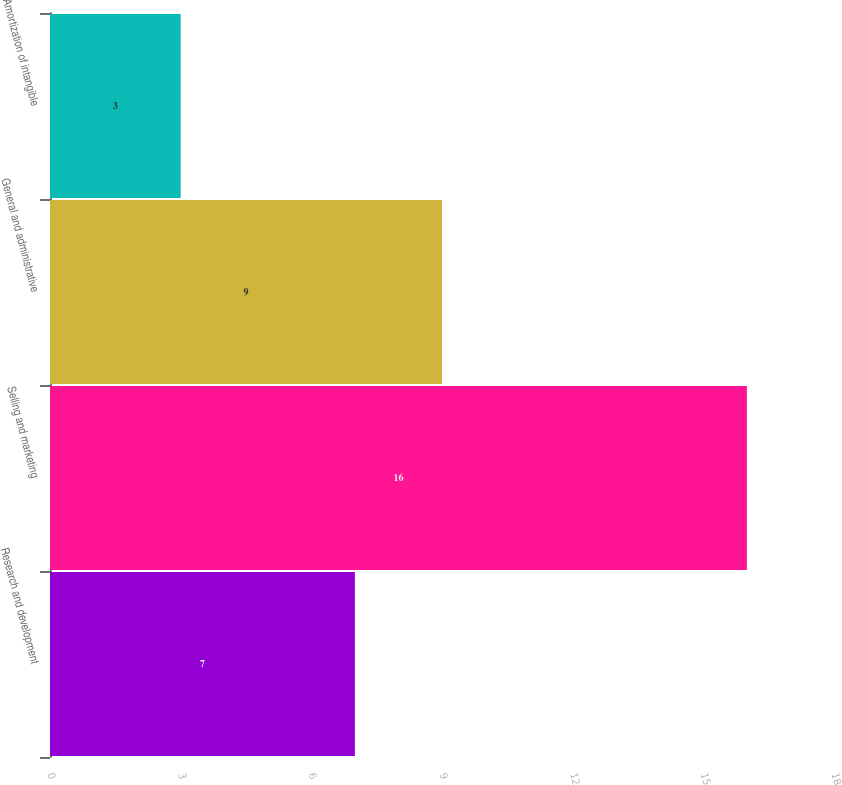Convert chart. <chart><loc_0><loc_0><loc_500><loc_500><bar_chart><fcel>Research and development<fcel>Selling and marketing<fcel>General and administrative<fcel>Amortization of intangible<nl><fcel>7<fcel>16<fcel>9<fcel>3<nl></chart> 